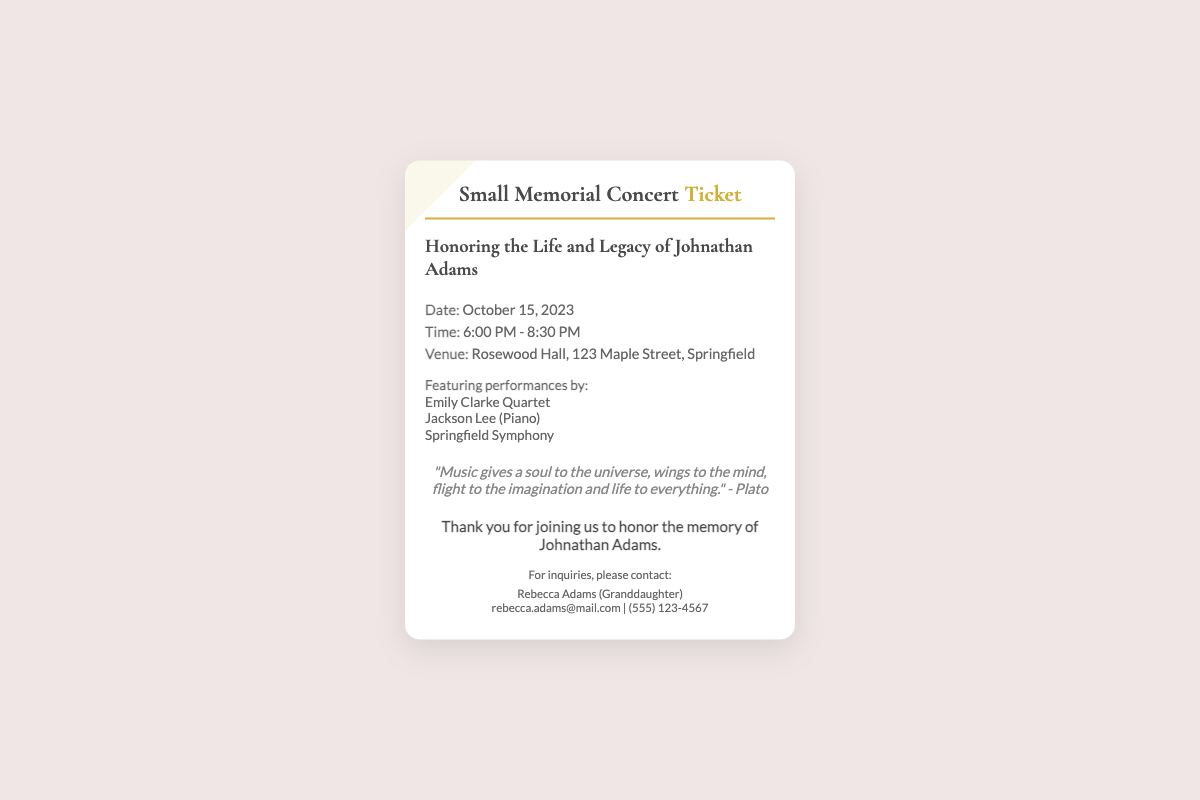What is the date of the concert? The date of the concert is specified in the details section of the ticket.
Answer: October 15, 2023 What time does the concert start? The start time of the concert is indicated in the details section of the ticket.
Answer: 6:00 PM Where is the concert being held? The venue for the concert is provided in the details section of the ticket.
Answer: Rosewood Hall, 123 Maple Street, Springfield Who is performing at the concert? The names of the performers are listed under the performances section of the ticket.
Answer: Emily Clarke Quartet, Jackson Lee, Springfield Symphony What is the theme of the event? The theme or purpose of the event is described in the title of the ticket.
Answer: Honoring the Life and Legacy of Johnathan Adams What quote is included in the ticket? The quote from Plato is featured in a specific section of the ticket.
Answer: "Music gives a soul to the universe, wings to the mind, flight to the imagination and life to everything." - Plato Who can be contacted for inquiries? The contact information is provided in the ticket for questions regarding the event.
Answer: Rebecca Adams What is the tone of the thank you message? The thank-you message conveys appreciation, which is typical for memorial events.
Answer: Thank you for joining us to honor the memory of Johnathan Adams 